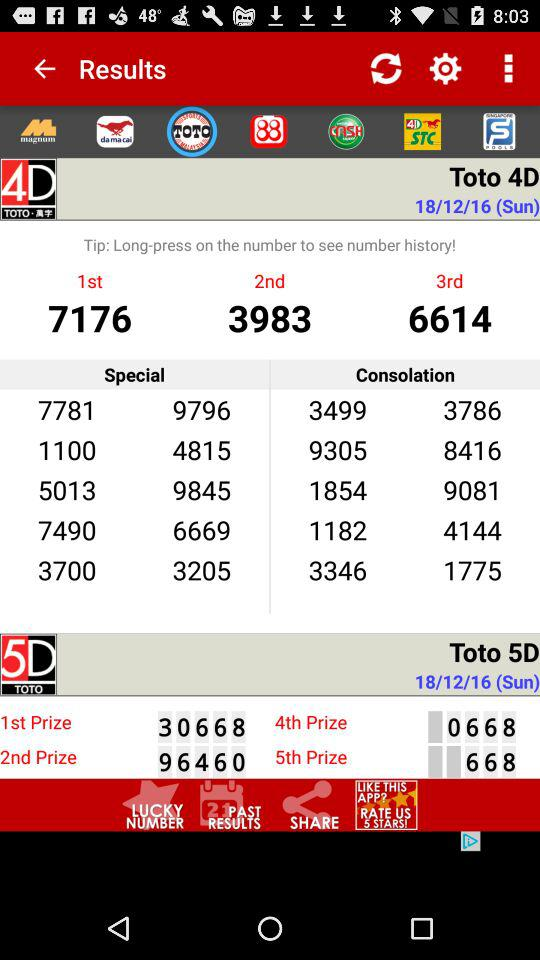What is the date of Toto 4D? The date is Sunday, December 18, 2016. 